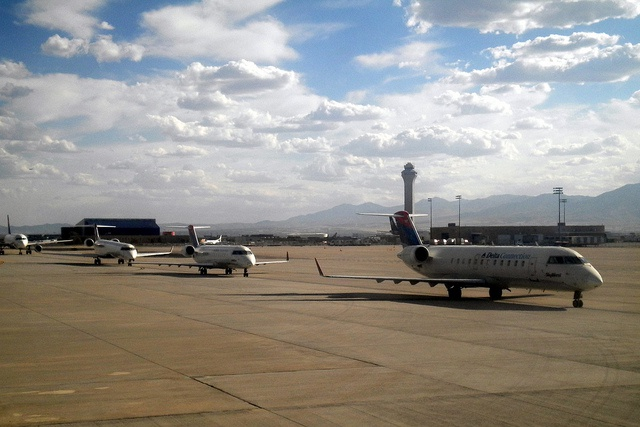Describe the objects in this image and their specific colors. I can see airplane in blue, black, gray, and darkgray tones, airplane in blue, gray, black, darkgray, and ivory tones, airplane in blue, black, gray, and ivory tones, airplane in blue, black, gray, and darkgray tones, and airplane in blue, white, darkgray, gray, and black tones in this image. 